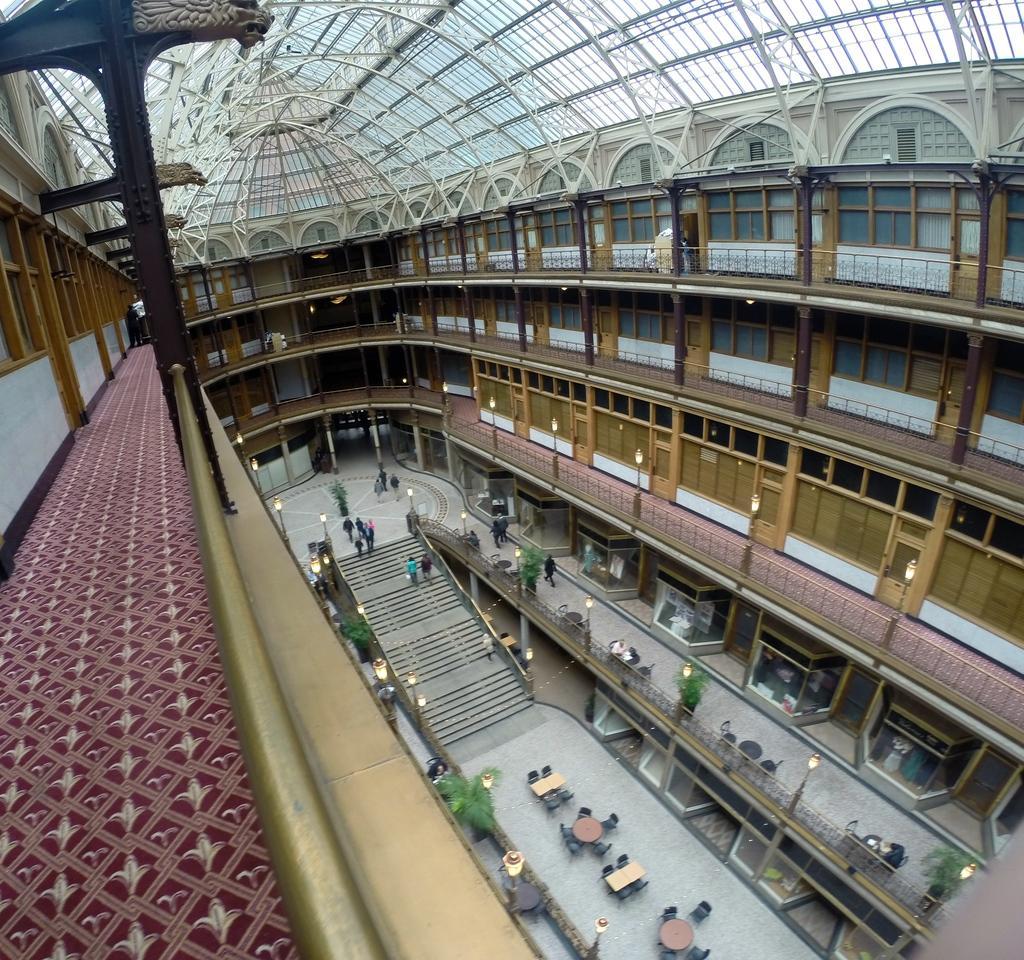Describe this image in one or two sentences. In this image we can see there is a building with so many floors and a curved roof, also there are so many people walking in the ground floor. 